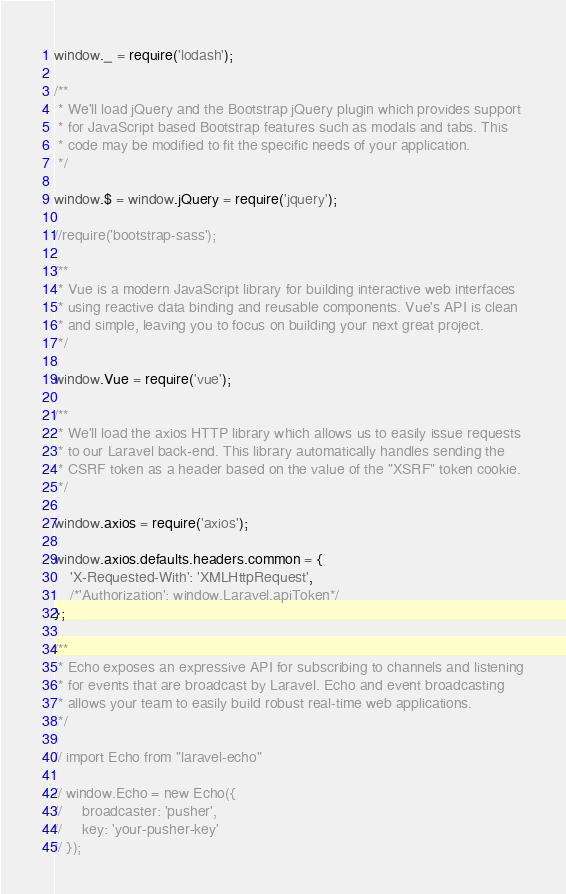<code> <loc_0><loc_0><loc_500><loc_500><_JavaScript_>
window._ = require('lodash');

/**
 * We'll load jQuery and the Bootstrap jQuery plugin which provides support
 * for JavaScript based Bootstrap features such as modals and tabs. This
 * code may be modified to fit the specific needs of your application.
 */

window.$ = window.jQuery = require('jquery');

//require('bootstrap-sass');

/**
 * Vue is a modern JavaScript library for building interactive web interfaces
 * using reactive data binding and reusable components. Vue's API is clean
 * and simple, leaving you to focus on building your next great project.
 */

window.Vue = require('vue');

/**
 * We'll load the axios HTTP library which allows us to easily issue requests
 * to our Laravel back-end. This library automatically handles sending the
 * CSRF token as a header based on the value of the "XSRF" token cookie.
 */

window.axios = require('axios');

window.axios.defaults.headers.common = {
    'X-Requested-With': 'XMLHttpRequest',
    /*'Authorization': window.Laravel.apiToken*/
};

/**
 * Echo exposes an expressive API for subscribing to channels and listening
 * for events that are broadcast by Laravel. Echo and event broadcasting
 * allows your team to easily build robust real-time web applications.
 */

// import Echo from "laravel-echo"

// window.Echo = new Echo({
//     broadcaster: 'pusher',
//     key: 'your-pusher-key'
// });
</code> 